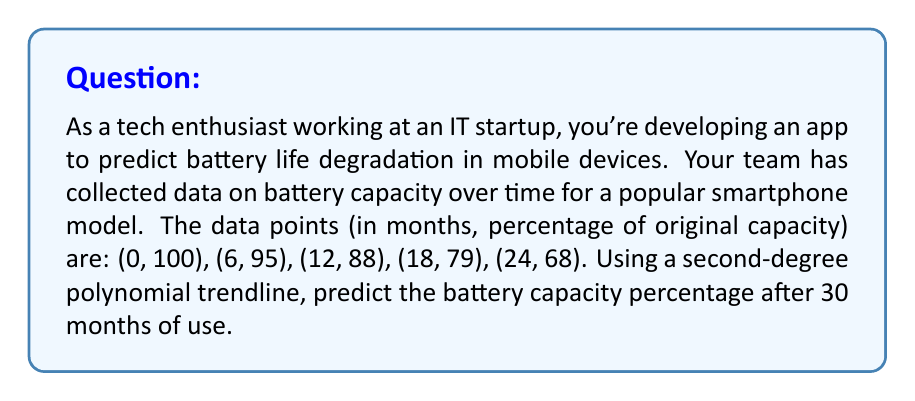Can you solve this math problem? To solve this problem, we'll follow these steps:

1) First, we need to find the equation of the second-degree polynomial trendline that best fits our data. The general form is:

   $$ y = ax^2 + bx + c $$

   where $y$ is the battery capacity percentage, and $x$ is the time in months.

2) We can use a polynomial regression calculator or spreadsheet software to find the coefficients $a$, $b$, and $c$. For this data set, we get:

   $$ y = -0.0052x^2 - 0.8448x + 100 $$

3) Now that we have our trendline equation, we can predict the battery capacity at 30 months by plugging in $x = 30$:

   $$ y = -0.0052(30)^2 - 0.8448(30) + 100 $$

4) Let's calculate step by step:
   
   $$ y = -0.0052(900) - 0.8448(30) + 100 $$
   $$ y = -4.68 - 25.344 + 100 $$
   $$ y = 69.976 $$

5) Rounding to the nearest whole percentage:

   $$ y \approx 70\% $$

Therefore, after 30 months of use, the battery is predicted to have approximately 70% of its original capacity.
Answer: 70% 